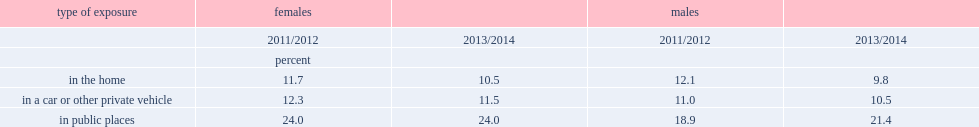What is the percentage of girls aged 12 to 17, who were non-smokers, reported having been exposed to second-hand smoke in their home in 2013/2014? 10.5. What is the percentage of girls aged 12 to 17, who were non-smokers, reported having been exposed to second-hand smoke in a vehicle in 2013/2014? 11.5. What is the percentage of girls aged 12 to 17, who were non-smokers, reported having been exposed to second-hand smoke in public places, such as bowling alleys and shopping malls in 2013/2014? 24.0. Which year were less likely to report exposure to smoke in their home in 2013/2014 than in 2011/2012 for 12- to 17-year-old boys, who were non-smokers? 2013/2014. What is the percentage of 12- to 17-year-old boys, who were non-smokers, would report exposure to smoke in their home in 2011/2012? 12.1. What is the percentage of 12- to 17-year-old boys, who were non-smokers, would report exposure to smoke in their home in 2013/2014? 9.8. Which year was more likely to report daily or near-daily exposure to smoke in public places between 2011/2012 to 2013/2014? 2013/2014. What is the percentage of boys would report daily or near-daily exposure to smoke in public places in 2011/2012? 21.4. What is the percentage of boys would report daily or near-daily exposure to smoke in public places in 2013/2014? 18.9. 